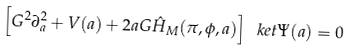<formula> <loc_0><loc_0><loc_500><loc_500>\left [ G ^ { 2 } \partial _ { a } ^ { 2 } + V ( a ) + 2 a G \hat { H } _ { M } ( \pi , \phi , a ) \right ] \ k e t { \Psi ( a ) } = 0</formula> 